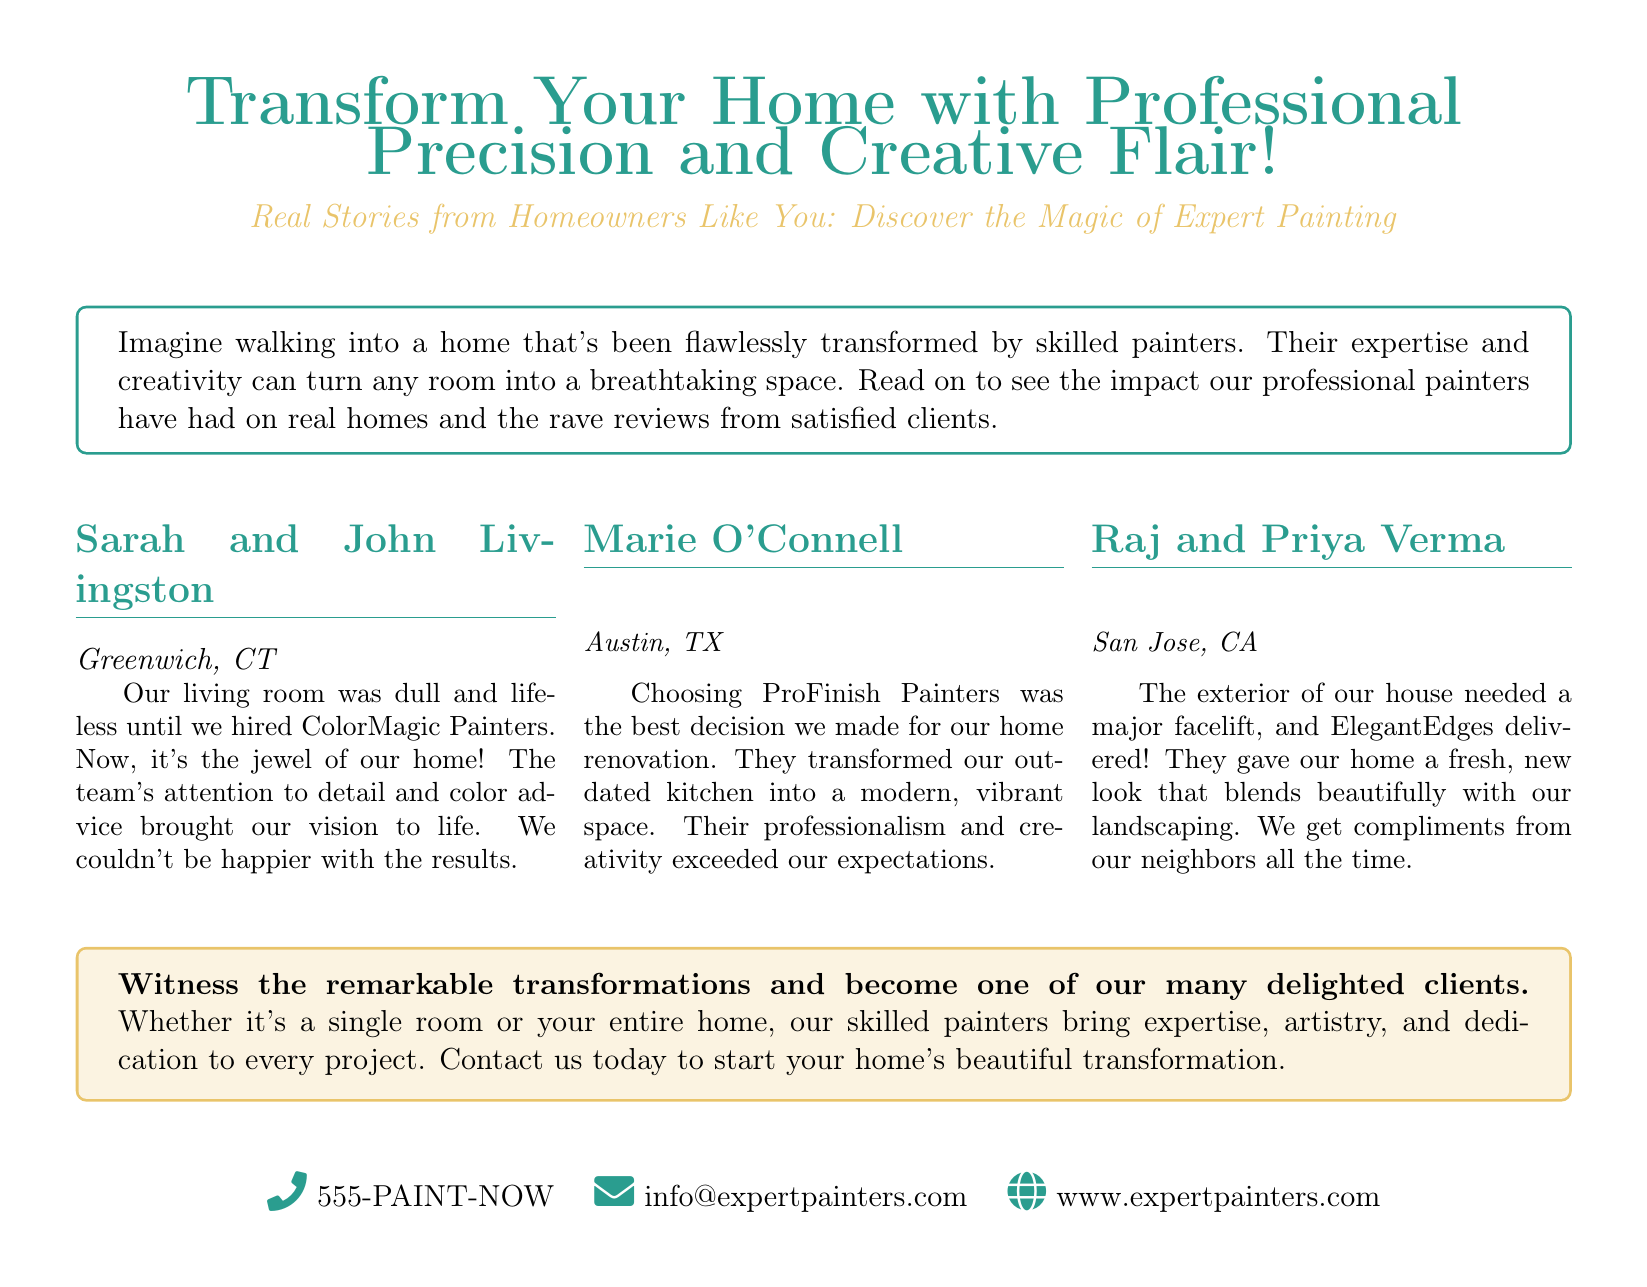What is the main purpose of the advertisement? The document promotes the services of professional painters and showcases client testimonials about home transformations.
Answer: Transform homes with professional precision and creative flair Who wrote the testimonial for the living room transformation? The testimonial for the living room transformation was written by Sarah and John Livingston.
Answer: Sarah and John Livingston What city is Marie O'Connell from? Marie O'Connell is from Austin, TX.
Answer: Austin, TX Which company transformed Raj and Priya Verma's home exterior? The exterior of Raj and Priya Verma's house was transformed by ElegantEdges.
Answer: ElegantEdges What key aspect did clients praise about the painters? Clients praised the painters' attention to detail and creativity.
Answer: Attention to detail and creativity How many client testimonials are included in the document? There are three client testimonials included in the document.
Answer: Three What contact method is provided for inquiries? The document provides a phone number for inquiries.
Answer: 555-PAINT-NOW What theme is highlighted in the clients' reviews? The theme highlighted is the transformation and improvement of living spaces.
Answer: Transformation and improvement What is indicated as the outcome of hiring the painters? The outcome of hiring the painters is a beautifully transformed home.
Answer: Beautifully transformed home 